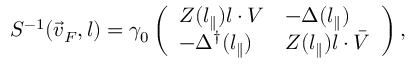Convert formula to latex. <formula><loc_0><loc_0><loc_500><loc_500>S ^ { - 1 } ( \vec { v } _ { F } , l ) = \gamma _ { 0 } \left ( \begin{array} { l l } { { Z ( l _ { \| } ) l \cdot V } } & { { - \Delta ( l _ { \| } ) } } \\ { { - \Delta ^ { \dagger } ( l _ { \| } ) } } & { { Z ( l _ { \| } ) l \cdot \bar { V } } } \end{array} \right ) ,</formula> 